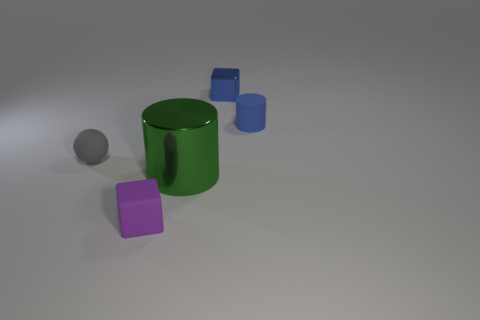What size is the cylinder in front of the small rubber thing to the right of the tiny purple matte object?
Your answer should be very brief. Large. Are there any other things that have the same size as the green metallic object?
Provide a short and direct response. No. There is another object that is the same shape as the big green shiny object; what material is it?
Your response must be concise. Rubber. Are there fewer large things left of the large green object than blocks that are behind the blue cylinder?
Your answer should be compact. Yes. How many other things are there of the same material as the green object?
Ensure brevity in your answer.  1. There is a purple object that is the same size as the blue cylinder; what is its material?
Offer a very short reply. Rubber. Are there fewer purple cubes that are to the right of the large green thing than large green shiny things?
Your answer should be very brief. Yes. What shape is the matte thing that is in front of the small object that is on the left side of the small matte object that is in front of the gray sphere?
Give a very brief answer. Cube. There is a block that is to the right of the small purple matte cube; what size is it?
Provide a succinct answer. Small. There is a gray thing that is the same size as the blue matte cylinder; what is its shape?
Your response must be concise. Sphere. 